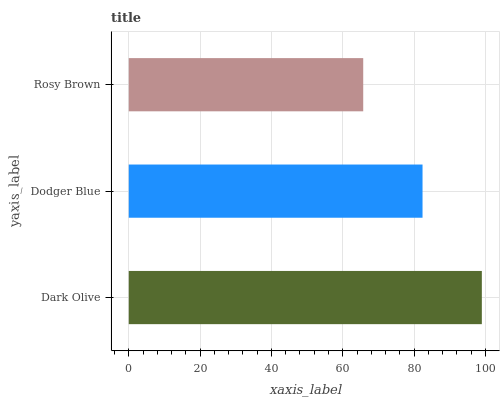Is Rosy Brown the minimum?
Answer yes or no. Yes. Is Dark Olive the maximum?
Answer yes or no. Yes. Is Dodger Blue the minimum?
Answer yes or no. No. Is Dodger Blue the maximum?
Answer yes or no. No. Is Dark Olive greater than Dodger Blue?
Answer yes or no. Yes. Is Dodger Blue less than Dark Olive?
Answer yes or no. Yes. Is Dodger Blue greater than Dark Olive?
Answer yes or no. No. Is Dark Olive less than Dodger Blue?
Answer yes or no. No. Is Dodger Blue the high median?
Answer yes or no. Yes. Is Dodger Blue the low median?
Answer yes or no. Yes. Is Dark Olive the high median?
Answer yes or no. No. Is Dark Olive the low median?
Answer yes or no. No. 